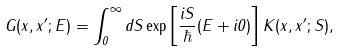Convert formula to latex. <formula><loc_0><loc_0><loc_500><loc_500>G ( x , x ^ { \prime } ; E ) = \int _ { 0 } ^ { \infty } d S \exp \left [ \frac { i S } \hbar { ( } E + i 0 ) \right ] K ( x , x ^ { \prime } ; S ) ,</formula> 